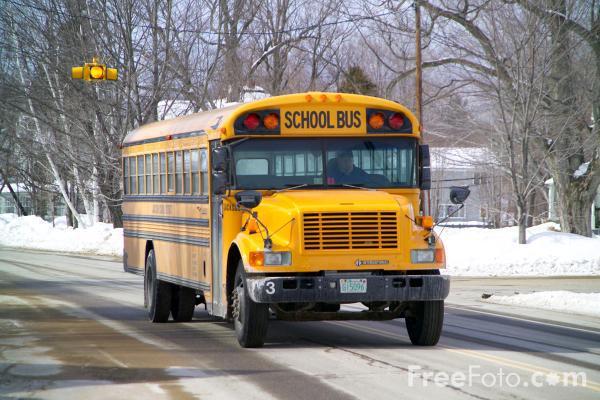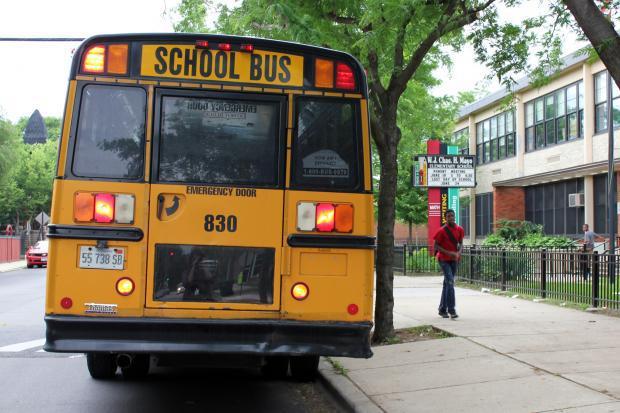The first image is the image on the left, the second image is the image on the right. Considering the images on both sides, is "People are standing outside near a bus in the image on the left." valid? Answer yes or no. No. The first image is the image on the left, the second image is the image on the right. Given the left and right images, does the statement "There are one or more people next to the school bus in one image, but not the other." hold true? Answer yes or no. Yes. 